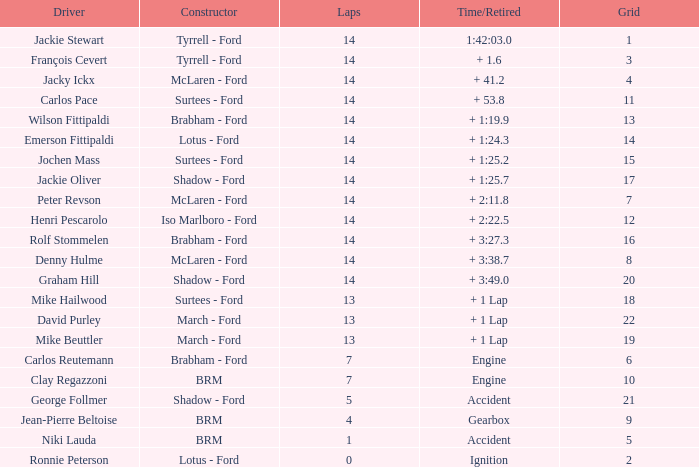Would you mind parsing the complete table? {'header': ['Driver', 'Constructor', 'Laps', 'Time/Retired', 'Grid'], 'rows': [['Jackie Stewart', 'Tyrrell - Ford', '14', '1:42:03.0', '1'], ['François Cevert', 'Tyrrell - Ford', '14', '+ 1.6', '3'], ['Jacky Ickx', 'McLaren - Ford', '14', '+ 41.2', '4'], ['Carlos Pace', 'Surtees - Ford', '14', '+ 53.8', '11'], ['Wilson Fittipaldi', 'Brabham - Ford', '14', '+ 1:19.9', '13'], ['Emerson Fittipaldi', 'Lotus - Ford', '14', '+ 1:24.3', '14'], ['Jochen Mass', 'Surtees - Ford', '14', '+ 1:25.2', '15'], ['Jackie Oliver', 'Shadow - Ford', '14', '+ 1:25.7', '17'], ['Peter Revson', 'McLaren - Ford', '14', '+ 2:11.8', '7'], ['Henri Pescarolo', 'Iso Marlboro - Ford', '14', '+ 2:22.5', '12'], ['Rolf Stommelen', 'Brabham - Ford', '14', '+ 3:27.3', '16'], ['Denny Hulme', 'McLaren - Ford', '14', '+ 3:38.7', '8'], ['Graham Hill', 'Shadow - Ford', '14', '+ 3:49.0', '20'], ['Mike Hailwood', 'Surtees - Ford', '13', '+ 1 Lap', '18'], ['David Purley', 'March - Ford', '13', '+ 1 Lap', '22'], ['Mike Beuttler', 'March - Ford', '13', '+ 1 Lap', '19'], ['Carlos Reutemann', 'Brabham - Ford', '7', 'Engine', '6'], ['Clay Regazzoni', 'BRM', '7', 'Engine', '10'], ['George Follmer', 'Shadow - Ford', '5', 'Accident', '21'], ['Jean-Pierre Beltoise', 'BRM', '4', 'Gearbox', '9'], ['Niki Lauda', 'BRM', '1', 'Accident', '5'], ['Ronnie Peterson', 'Lotus - Ford', '0', 'Ignition', '2']]} What is the low lap total for henri pescarolo with a grad larger than 6? 14.0. 